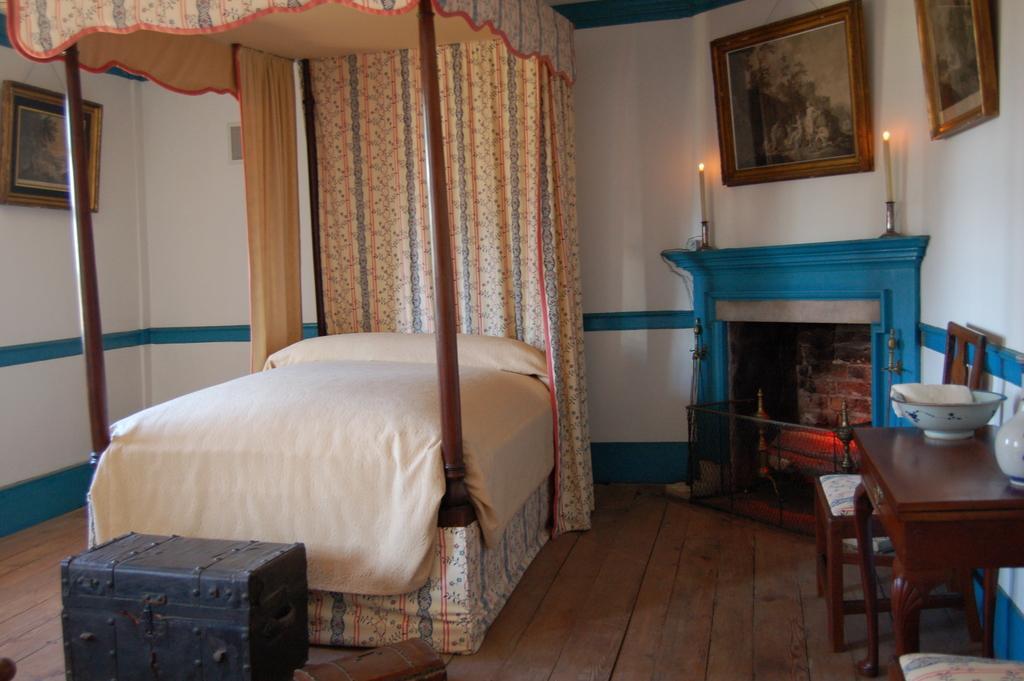Can you describe this image briefly? In this picture we can see frames over a wall. This is a chimney and we can see candles. On the table we can see a dish and a vase. This is a chair. Here we can see a bed cot with beautiful curtains. This is a floor. Here we can see a box. 